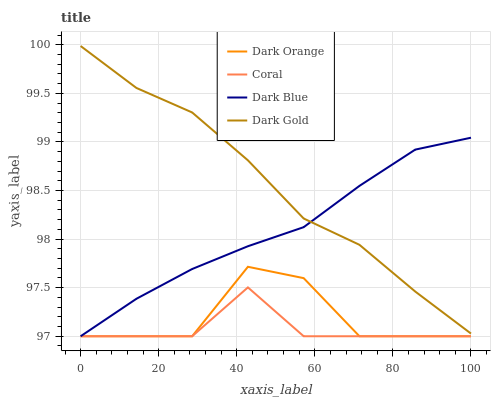Does Coral have the minimum area under the curve?
Answer yes or no. Yes. Does Dark Gold have the maximum area under the curve?
Answer yes or no. Yes. Does Dark Gold have the minimum area under the curve?
Answer yes or no. No. Does Coral have the maximum area under the curve?
Answer yes or no. No. Is Dark Blue the smoothest?
Answer yes or no. Yes. Is Dark Orange the roughest?
Answer yes or no. Yes. Is Coral the smoothest?
Answer yes or no. No. Is Coral the roughest?
Answer yes or no. No. Does Dark Orange have the lowest value?
Answer yes or no. Yes. Does Dark Gold have the lowest value?
Answer yes or no. No. Does Dark Gold have the highest value?
Answer yes or no. Yes. Does Coral have the highest value?
Answer yes or no. No. Is Dark Orange less than Dark Gold?
Answer yes or no. Yes. Is Dark Gold greater than Dark Orange?
Answer yes or no. Yes. Does Dark Orange intersect Dark Blue?
Answer yes or no. Yes. Is Dark Orange less than Dark Blue?
Answer yes or no. No. Is Dark Orange greater than Dark Blue?
Answer yes or no. No. Does Dark Orange intersect Dark Gold?
Answer yes or no. No. 